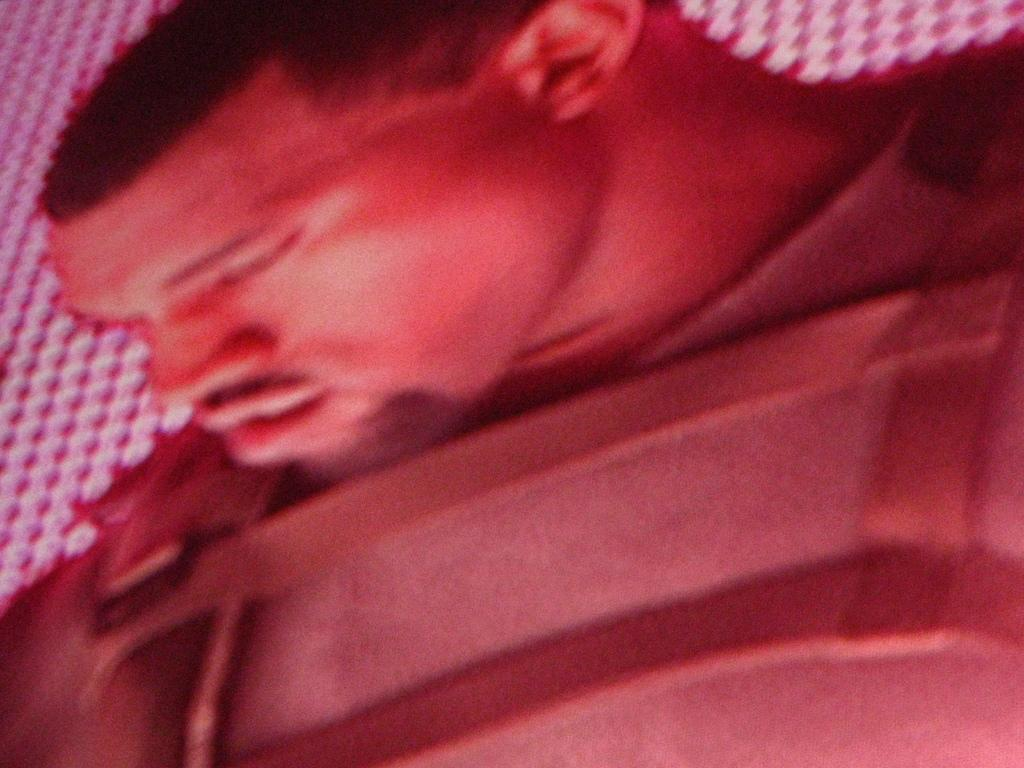What is the main subject of the image? There is a man in the image. Can you describe anything in the background of the image? There is a cloth visible in the background of the image. What type of ornament is hanging from the man's neck in the image? There is no ornament visible around the man's neck in the image. How much tax does the man owe in the image? There is no information about taxes in the image. 